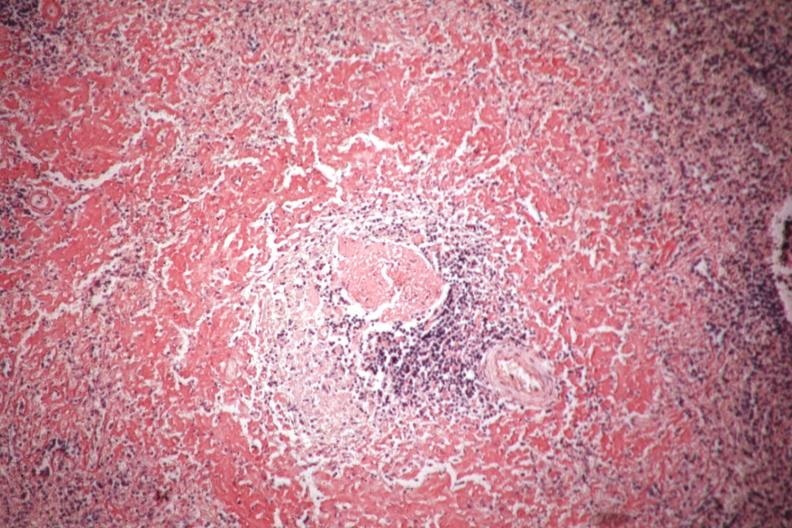what is congo red shown?
Answer the question using a single word or phrase. Perifollicular amyloid 